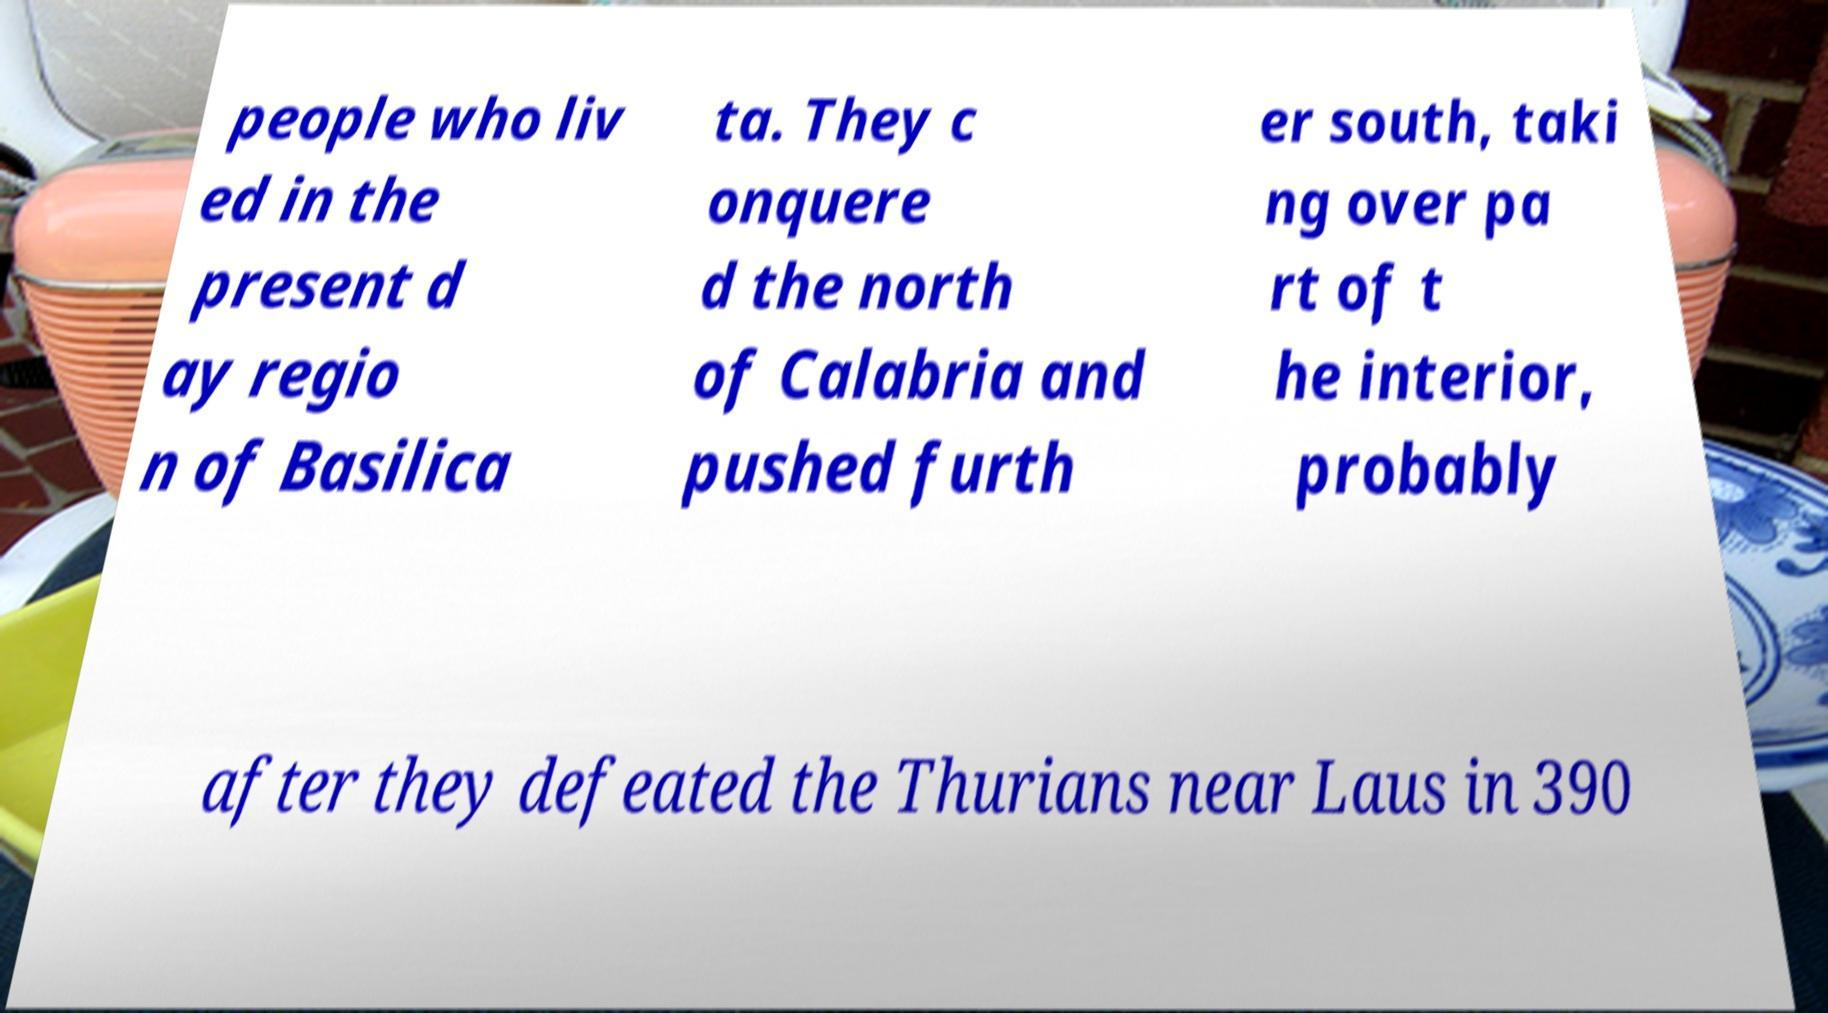Can you accurately transcribe the text from the provided image for me? people who liv ed in the present d ay regio n of Basilica ta. They c onquere d the north of Calabria and pushed furth er south, taki ng over pa rt of t he interior, probably after they defeated the Thurians near Laus in 390 